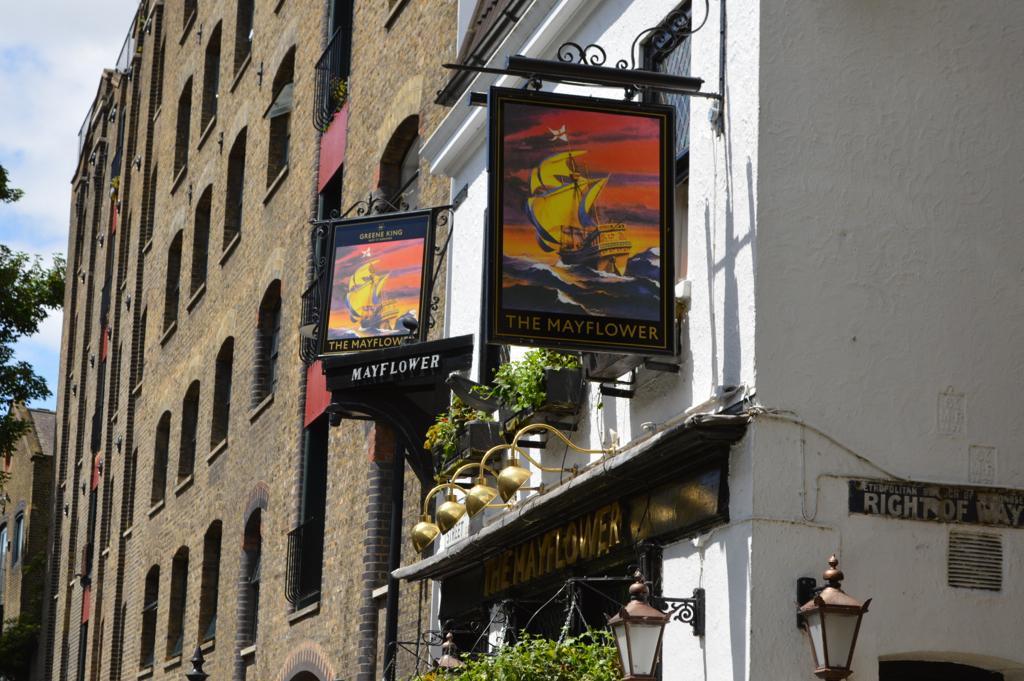How would you summarize this image in a sentence or two? In this image we can see buildings, banners and potted plants. At the bottom of the image, we can see leaves and lights. On the left side of the image, we can see the sky and a branch of a tree. 